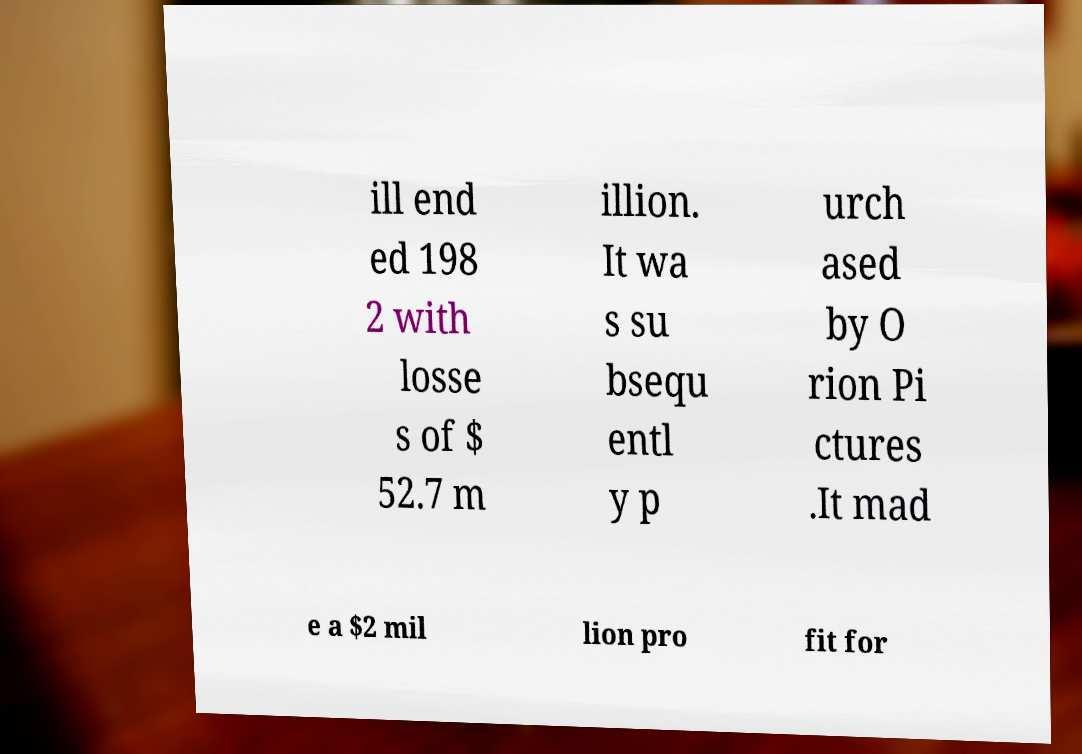Please identify and transcribe the text found in this image. ill end ed 198 2 with losse s of $ 52.7 m illion. It wa s su bsequ entl y p urch ased by O rion Pi ctures .It mad e a $2 mil lion pro fit for 